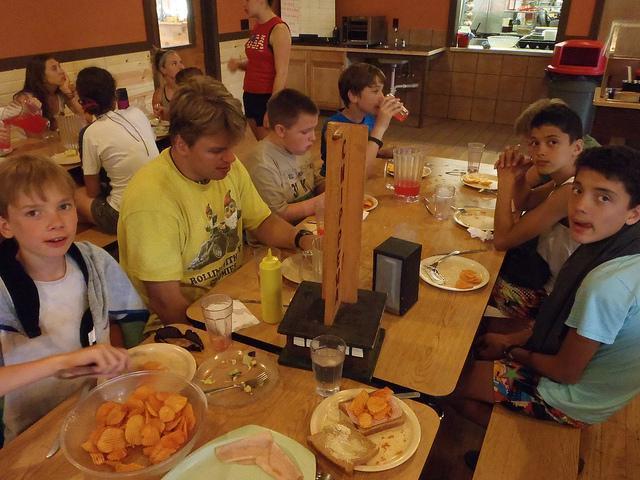How many people were sitting at  the table?
Give a very brief answer. 7. How many people can you see?
Give a very brief answer. 8. How many dining tables can be seen?
Give a very brief answer. 2. How many motorcycles are pictured?
Give a very brief answer. 0. 